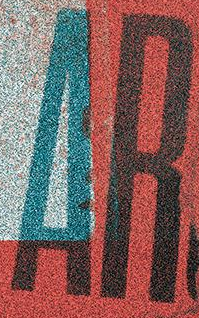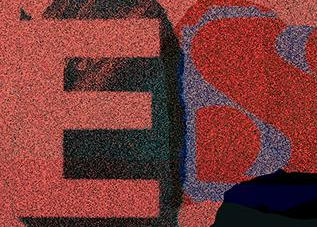What words are shown in these images in order, separated by a semicolon? AR; ES 